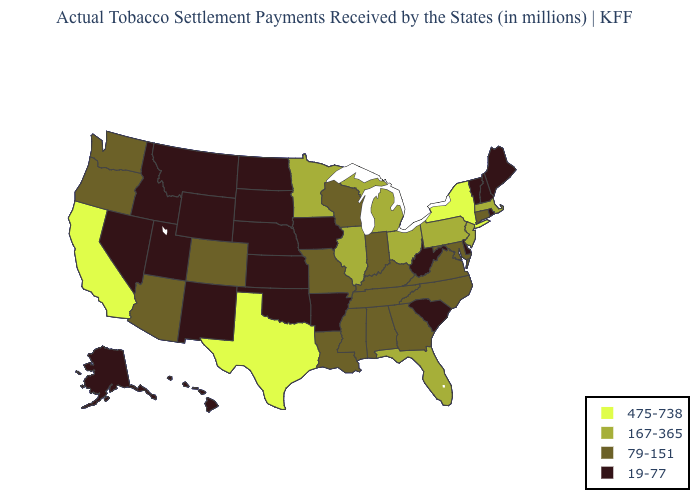What is the value of Tennessee?
Answer briefly. 79-151. What is the value of New Mexico?
Write a very short answer. 19-77. What is the value of Wyoming?
Concise answer only. 19-77. What is the highest value in states that border Texas?
Quick response, please. 79-151. Does Washington have a lower value than Oregon?
Answer briefly. No. Does Delaware have the highest value in the South?
Be succinct. No. Name the states that have a value in the range 19-77?
Answer briefly. Alaska, Arkansas, Delaware, Hawaii, Idaho, Iowa, Kansas, Maine, Montana, Nebraska, Nevada, New Hampshire, New Mexico, North Dakota, Oklahoma, Rhode Island, South Carolina, South Dakota, Utah, Vermont, West Virginia, Wyoming. Which states have the highest value in the USA?
Give a very brief answer. California, New York, Texas. Name the states that have a value in the range 167-365?
Be succinct. Florida, Illinois, Massachusetts, Michigan, Minnesota, New Jersey, Ohio, Pennsylvania. Does Arkansas have the same value as Washington?
Keep it brief. No. Does Vermont have the lowest value in the USA?
Short answer required. Yes. Among the states that border Indiana , which have the highest value?
Give a very brief answer. Illinois, Michigan, Ohio. Does Mississippi have a higher value than Indiana?
Quick response, please. No. Among the states that border Michigan , which have the highest value?
Short answer required. Ohio. How many symbols are there in the legend?
Quick response, please. 4. 